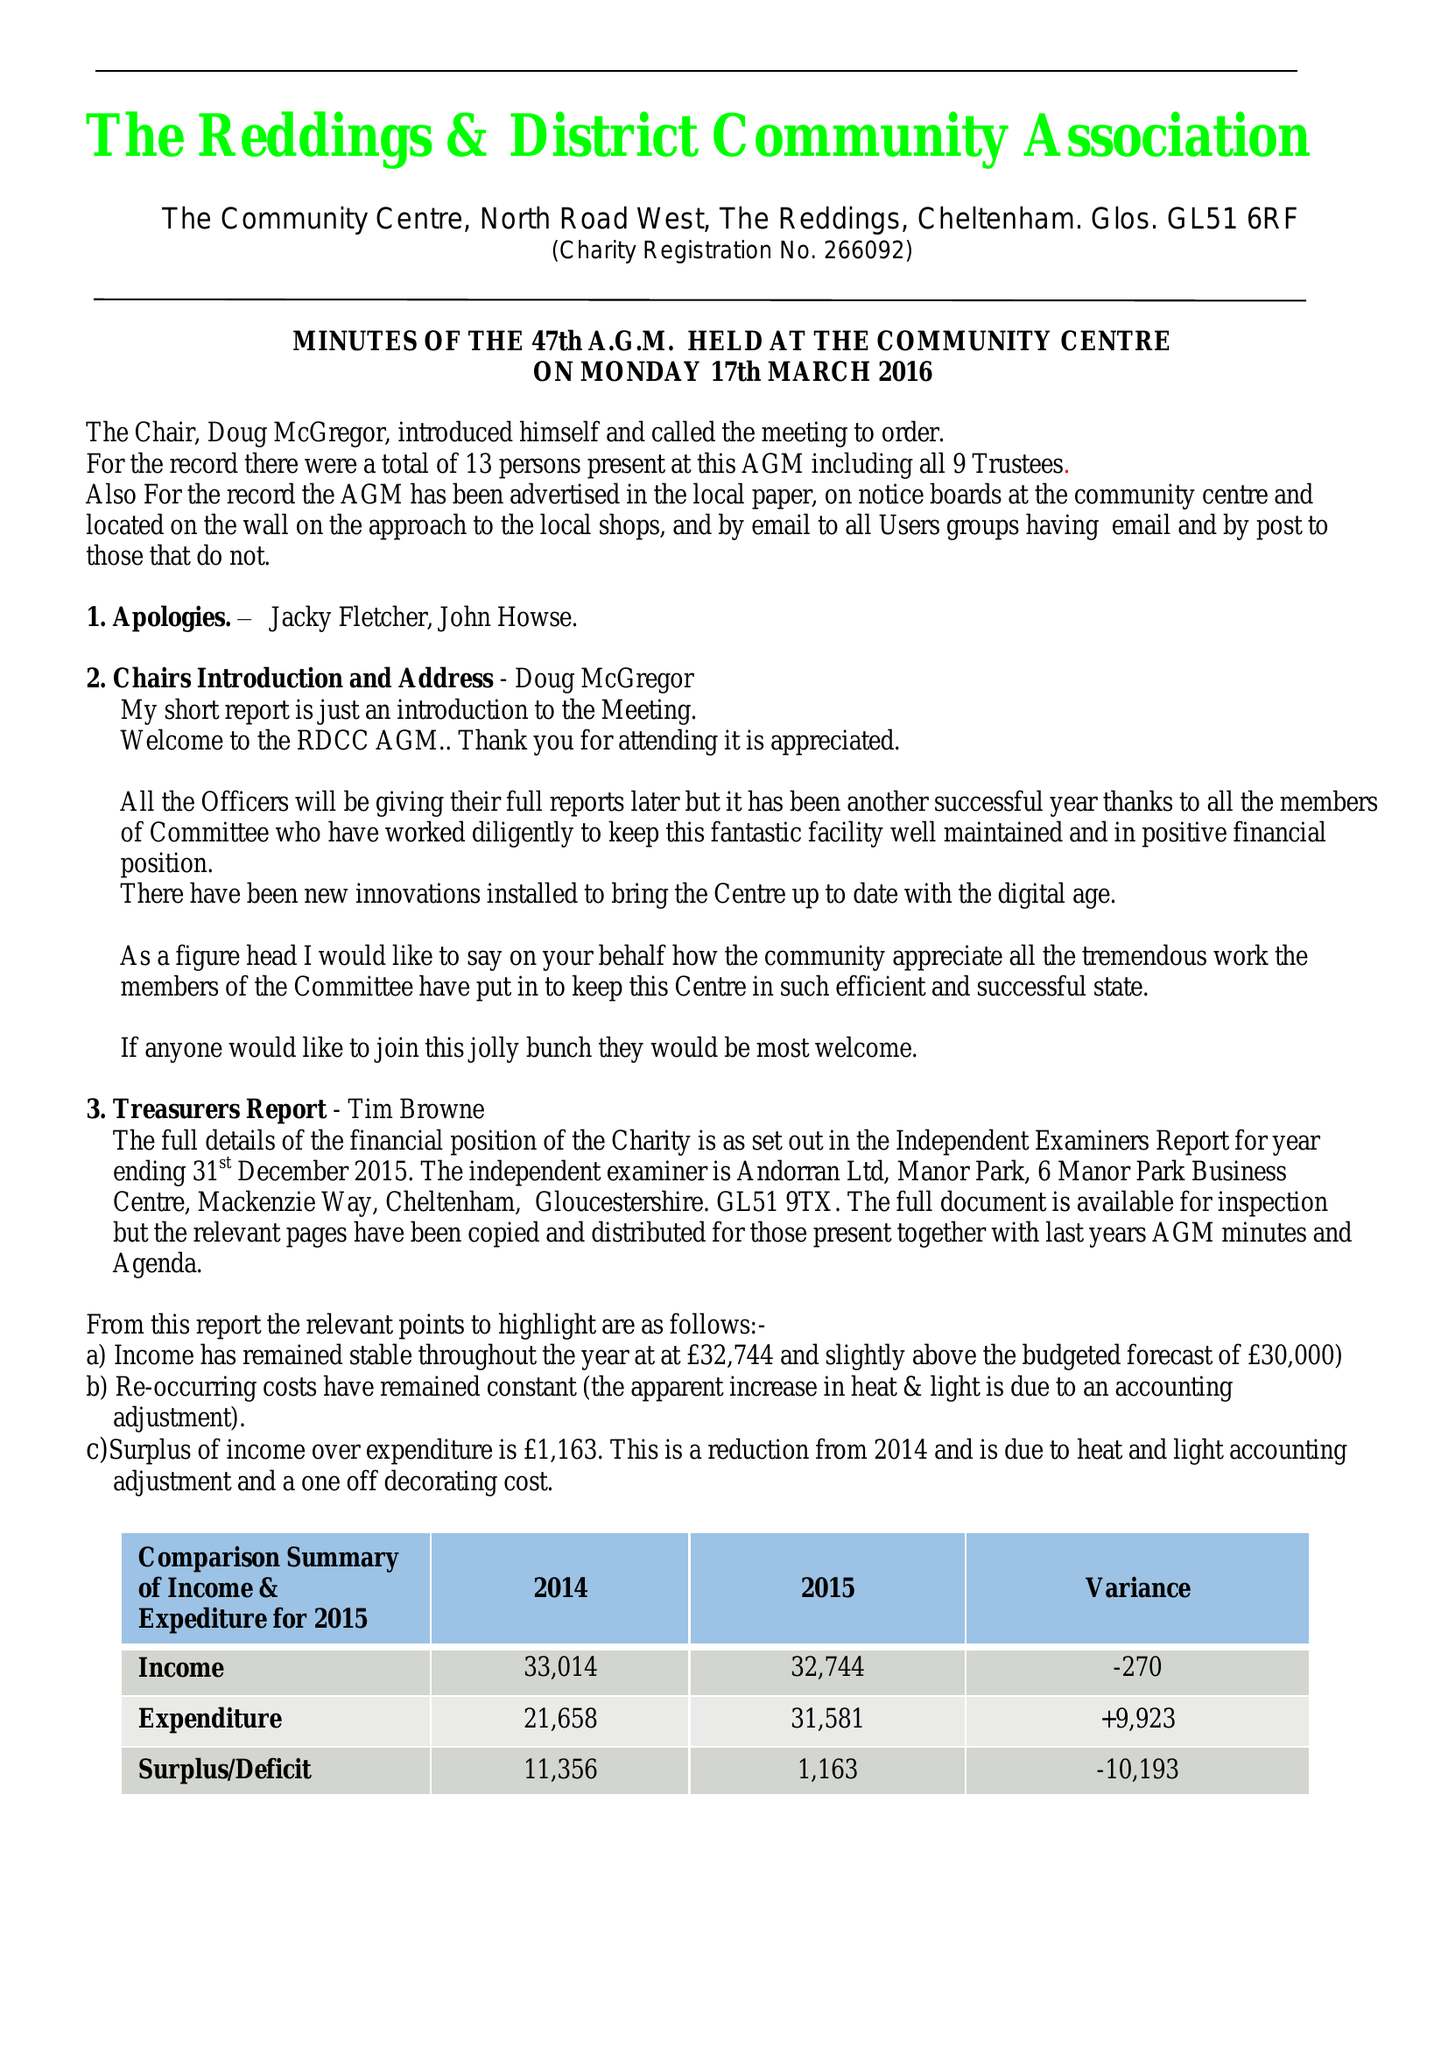What is the value for the spending_annually_in_british_pounds?
Answer the question using a single word or phrase. 31581.00 